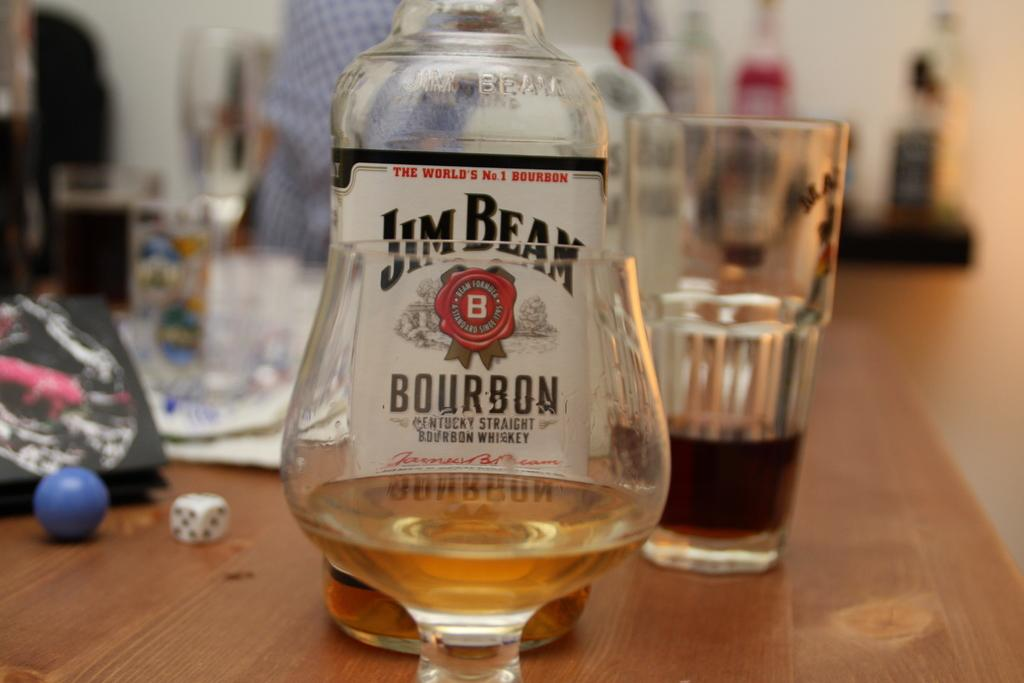Provide a one-sentence caption for the provided image. a bottle of Jim Beam Bourbon standing behind a glass. 